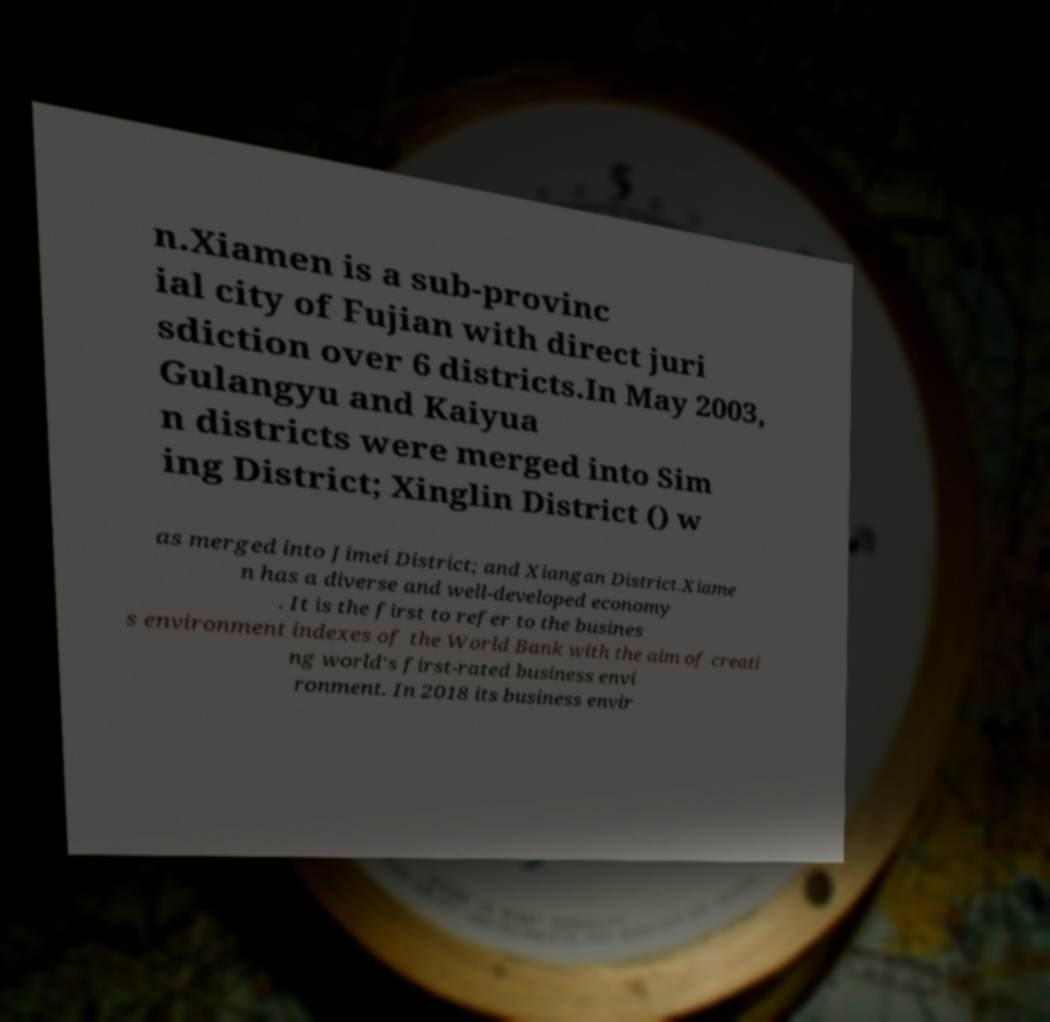Can you read and provide the text displayed in the image?This photo seems to have some interesting text. Can you extract and type it out for me? n.Xiamen is a sub-provinc ial city of Fujian with direct juri sdiction over 6 districts.In May 2003, Gulangyu and Kaiyua n districts were merged into Sim ing District; Xinglin District () w as merged into Jimei District; and Xiangan District.Xiame n has a diverse and well-developed economy . It is the first to refer to the busines s environment indexes of the World Bank with the aim of creati ng world's first-rated business envi ronment. In 2018 its business envir 